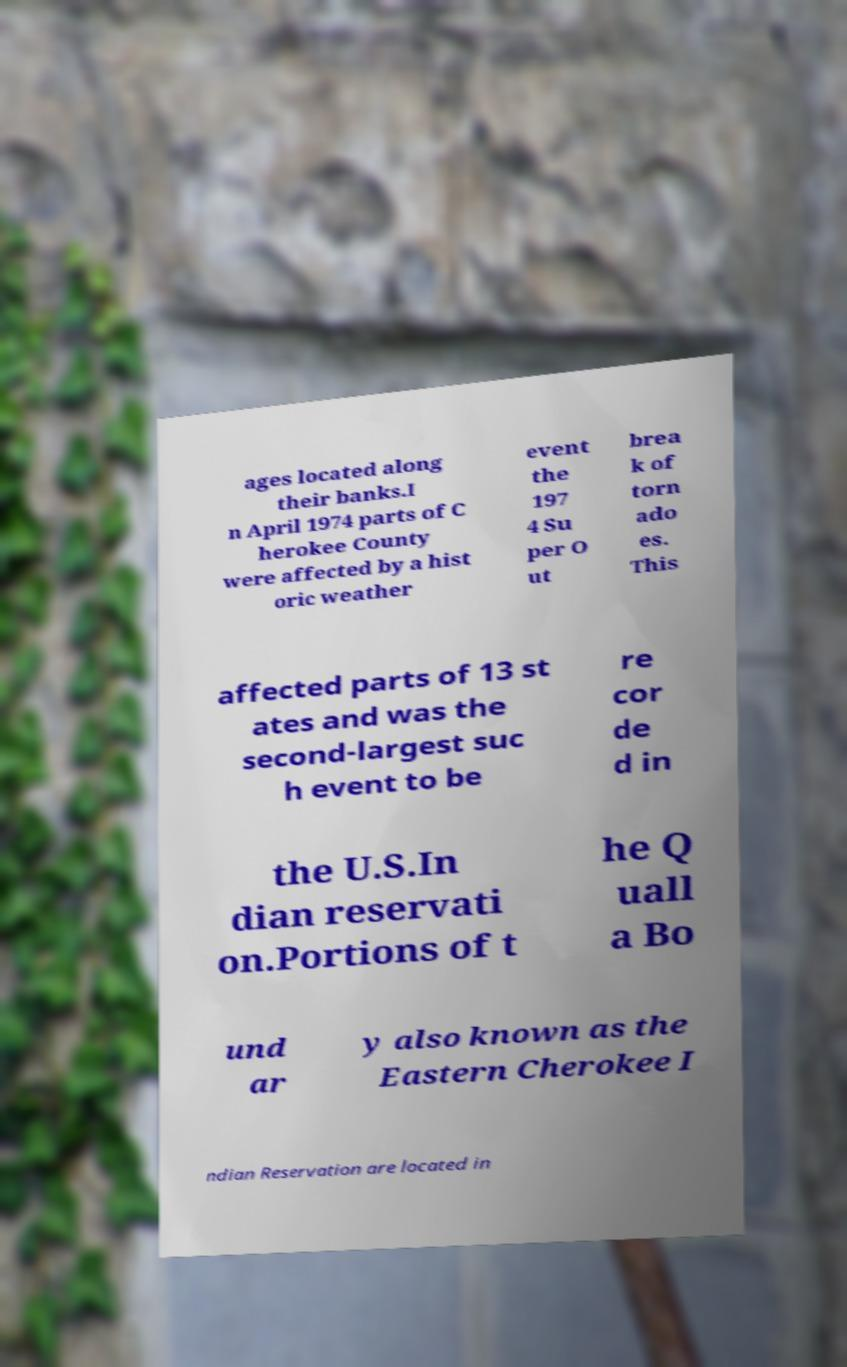What messages or text are displayed in this image? I need them in a readable, typed format. ages located along their banks.I n April 1974 parts of C herokee County were affected by a hist oric weather event the 197 4 Su per O ut brea k of torn ado es. This affected parts of 13 st ates and was the second-largest suc h event to be re cor de d in the U.S.In dian reservati on.Portions of t he Q uall a Bo und ar y also known as the Eastern Cherokee I ndian Reservation are located in 